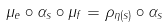<formula> <loc_0><loc_0><loc_500><loc_500>\mu _ { e } \circ \alpha _ { s } \circ \mu _ { f } = \rho _ { \eta ( s ) } \circ \alpha _ { s }</formula> 